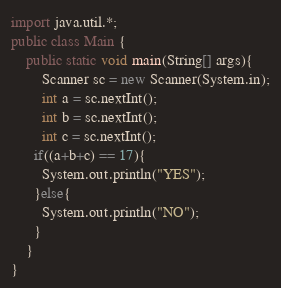Convert code to text. <code><loc_0><loc_0><loc_500><loc_500><_Java_>import java.util.*;
public class Main {
	public static void main(String[] args){
		Scanner sc = new Scanner(System.in);
		int a = sc.nextInt();
		int b = sc.nextInt();
		int c = sc.nextInt();
      if((a+b+c) == 17){
        System.out.println("YES");
      }else{
        System.out.println("NO");
      }
	}
}</code> 